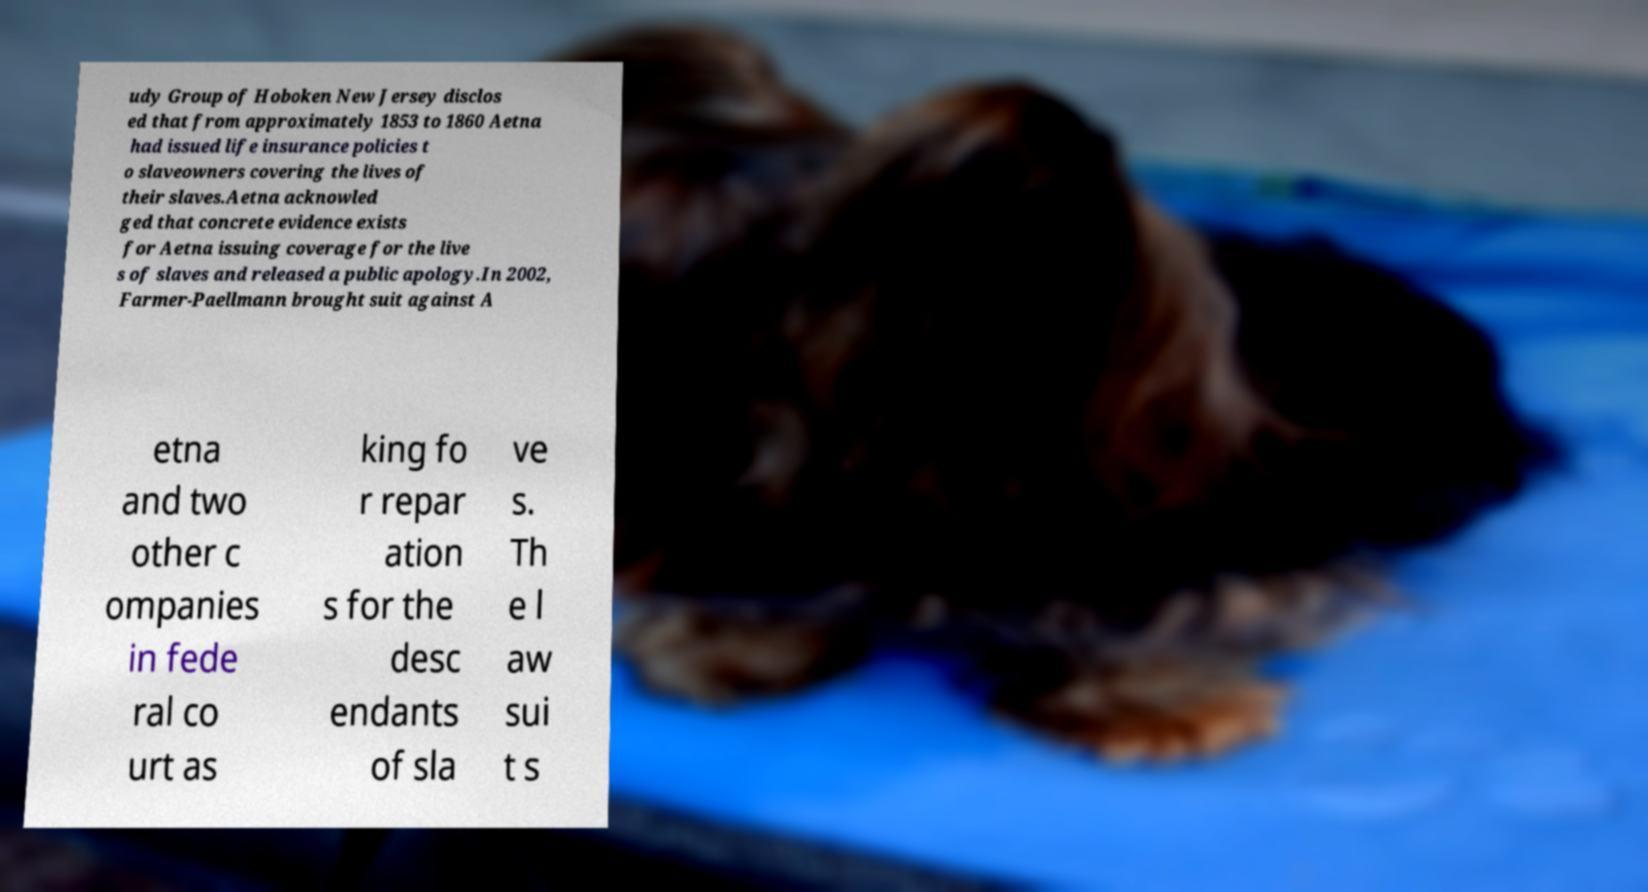For documentation purposes, I need the text within this image transcribed. Could you provide that? udy Group of Hoboken New Jersey disclos ed that from approximately 1853 to 1860 Aetna had issued life insurance policies t o slaveowners covering the lives of their slaves.Aetna acknowled ged that concrete evidence exists for Aetna issuing coverage for the live s of slaves and released a public apology.In 2002, Farmer-Paellmann brought suit against A etna and two other c ompanies in fede ral co urt as king fo r repar ation s for the desc endants of sla ve s. Th e l aw sui t s 